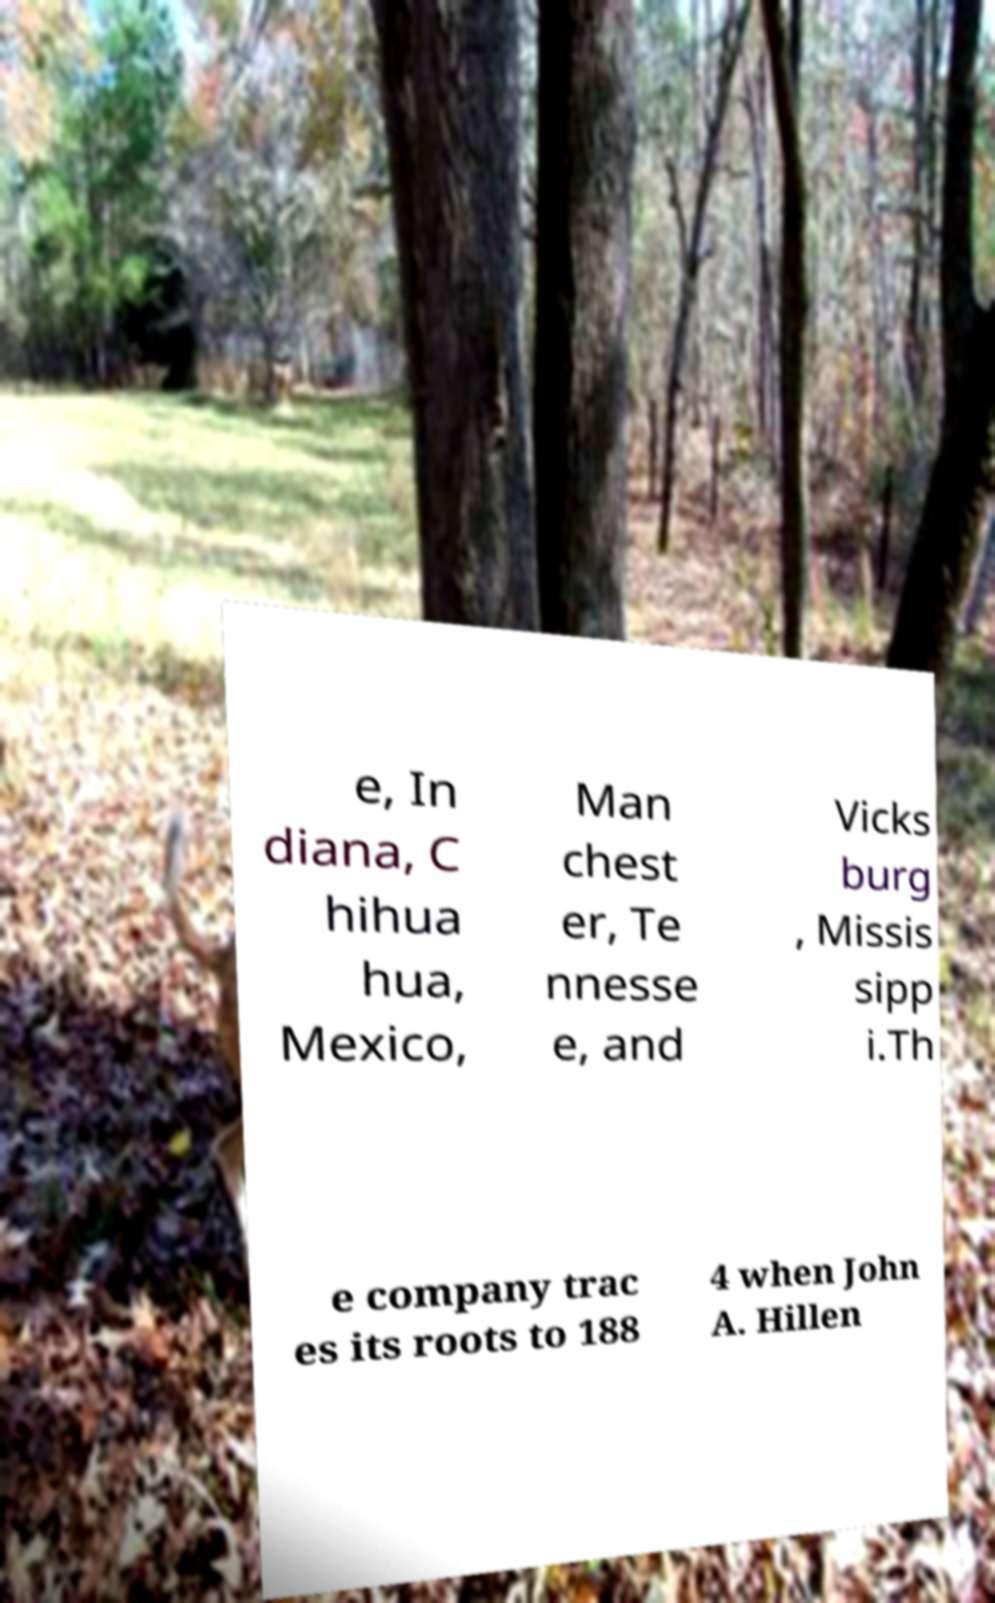What messages or text are displayed in this image? I need them in a readable, typed format. e, In diana, C hihua hua, Mexico, Man chest er, Te nnesse e, and Vicks burg , Missis sipp i.Th e company trac es its roots to 188 4 when John A. Hillen 